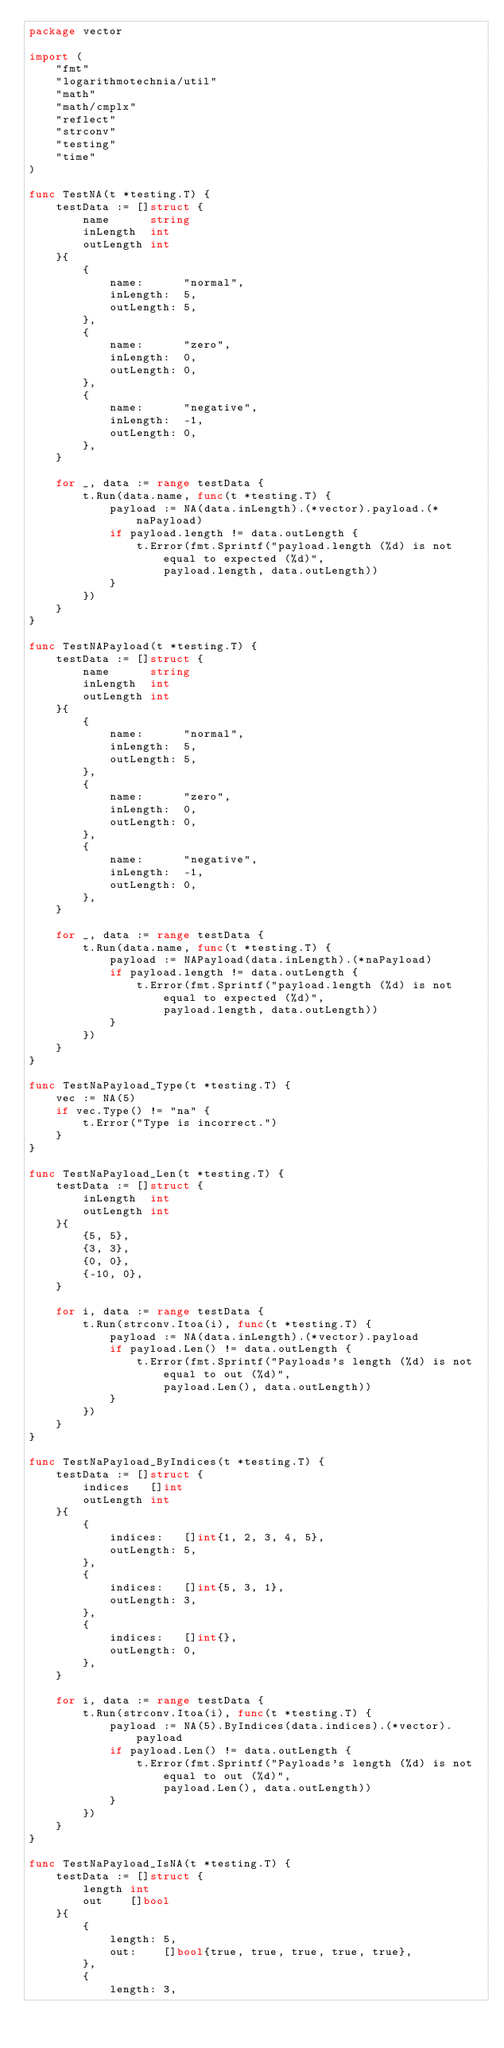Convert code to text. <code><loc_0><loc_0><loc_500><loc_500><_Go_>package vector

import (
	"fmt"
	"logarithmotechnia/util"
	"math"
	"math/cmplx"
	"reflect"
	"strconv"
	"testing"
	"time"
)

func TestNA(t *testing.T) {
	testData := []struct {
		name      string
		inLength  int
		outLength int
	}{
		{
			name:      "normal",
			inLength:  5,
			outLength: 5,
		},
		{
			name:      "zero",
			inLength:  0,
			outLength: 0,
		},
		{
			name:      "negative",
			inLength:  -1,
			outLength: 0,
		},
	}

	for _, data := range testData {
		t.Run(data.name, func(t *testing.T) {
			payload := NA(data.inLength).(*vector).payload.(*naPayload)
			if payload.length != data.outLength {
				t.Error(fmt.Sprintf("payload.length (%d) is not equal to expected (%d)",
					payload.length, data.outLength))
			}
		})
	}
}

func TestNAPayload(t *testing.T) {
	testData := []struct {
		name      string
		inLength  int
		outLength int
	}{
		{
			name:      "normal",
			inLength:  5,
			outLength: 5,
		},
		{
			name:      "zero",
			inLength:  0,
			outLength: 0,
		},
		{
			name:      "negative",
			inLength:  -1,
			outLength: 0,
		},
	}

	for _, data := range testData {
		t.Run(data.name, func(t *testing.T) {
			payload := NAPayload(data.inLength).(*naPayload)
			if payload.length != data.outLength {
				t.Error(fmt.Sprintf("payload.length (%d) is not equal to expected (%d)",
					payload.length, data.outLength))
			}
		})
	}
}

func TestNaPayload_Type(t *testing.T) {
	vec := NA(5)
	if vec.Type() != "na" {
		t.Error("Type is incorrect.")
	}
}

func TestNaPayload_Len(t *testing.T) {
	testData := []struct {
		inLength  int
		outLength int
	}{
		{5, 5},
		{3, 3},
		{0, 0},
		{-10, 0},
	}

	for i, data := range testData {
		t.Run(strconv.Itoa(i), func(t *testing.T) {
			payload := NA(data.inLength).(*vector).payload
			if payload.Len() != data.outLength {
				t.Error(fmt.Sprintf("Payloads's length (%d) is not equal to out (%d)",
					payload.Len(), data.outLength))
			}
		})
	}
}

func TestNaPayload_ByIndices(t *testing.T) {
	testData := []struct {
		indices   []int
		outLength int
	}{
		{
			indices:   []int{1, 2, 3, 4, 5},
			outLength: 5,
		},
		{
			indices:   []int{5, 3, 1},
			outLength: 3,
		},
		{
			indices:   []int{},
			outLength: 0,
		},
	}

	for i, data := range testData {
		t.Run(strconv.Itoa(i), func(t *testing.T) {
			payload := NA(5).ByIndices(data.indices).(*vector).payload
			if payload.Len() != data.outLength {
				t.Error(fmt.Sprintf("Payloads's length (%d) is not equal to out (%d)",
					payload.Len(), data.outLength))
			}
		})
	}
}

func TestNaPayload_IsNA(t *testing.T) {
	testData := []struct {
		length int
		out    []bool
	}{
		{
			length: 5,
			out:    []bool{true, true, true, true, true},
		},
		{
			length: 3,</code> 